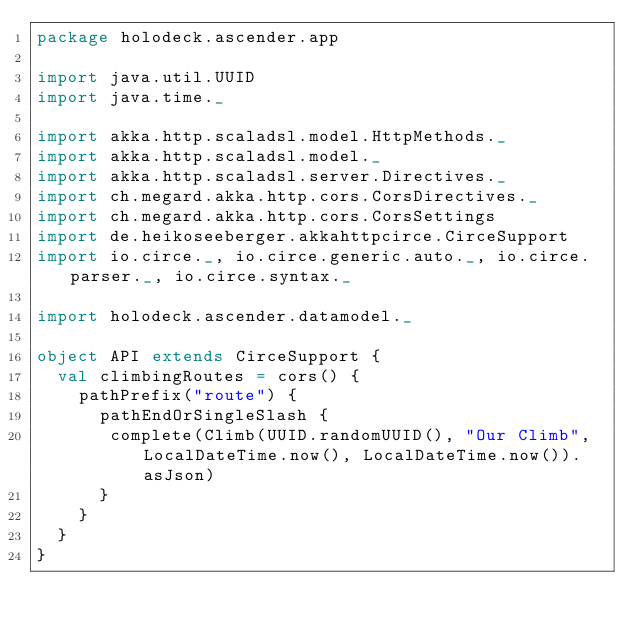Convert code to text. <code><loc_0><loc_0><loc_500><loc_500><_Scala_>package holodeck.ascender.app

import java.util.UUID
import java.time._

import akka.http.scaladsl.model.HttpMethods._
import akka.http.scaladsl.model._
import akka.http.scaladsl.server.Directives._
import ch.megard.akka.http.cors.CorsDirectives._
import ch.megard.akka.http.cors.CorsSettings
import de.heikoseeberger.akkahttpcirce.CirceSupport
import io.circe._, io.circe.generic.auto._, io.circe.parser._, io.circe.syntax._

import holodeck.ascender.datamodel._

object API extends CirceSupport {
  val climbingRoutes = cors() {
    pathPrefix("route") {
      pathEndOrSingleSlash {
       complete(Climb(UUID.randomUUID(), "Our Climb", LocalDateTime.now(), LocalDateTime.now()).asJson)
      }
    }
  }
}
</code> 